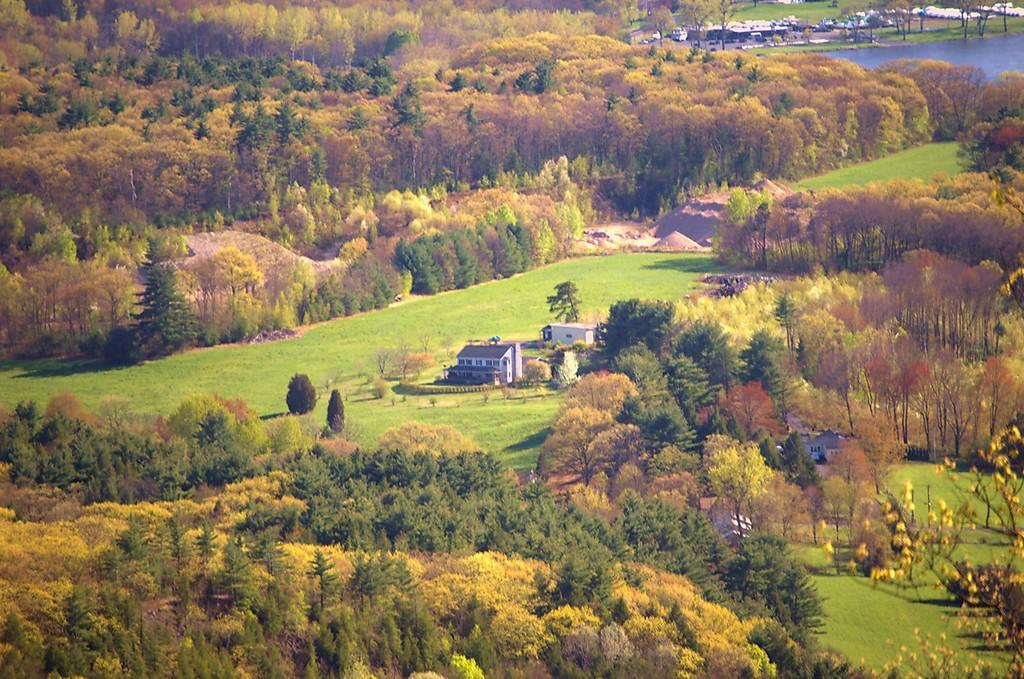What type of vegetation can be seen in the image? There are trees in the image. What type of structures are visible in the image? There are houses in the image. What is the ground covered with in the image? There is grass in the image. What can be seen in the top right corner of the image? There is water visible in the top right corner of the image. How many feet are visible in the image? There are no feet visible in the image. What type of thrill can be experienced by the water in the image? The image does not depict any thrill or emotion associated with the water. 